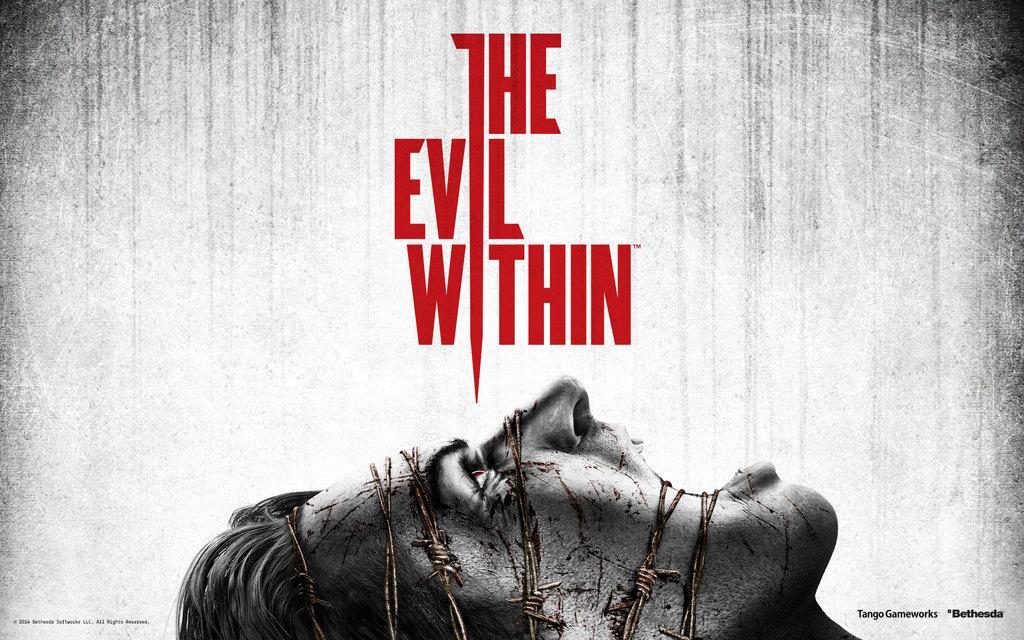Can you describe this image briefly? In this image I can see a person's face is tied with metal wire. Something is written on the image. At the bottom right side of the image there is a watermark. 